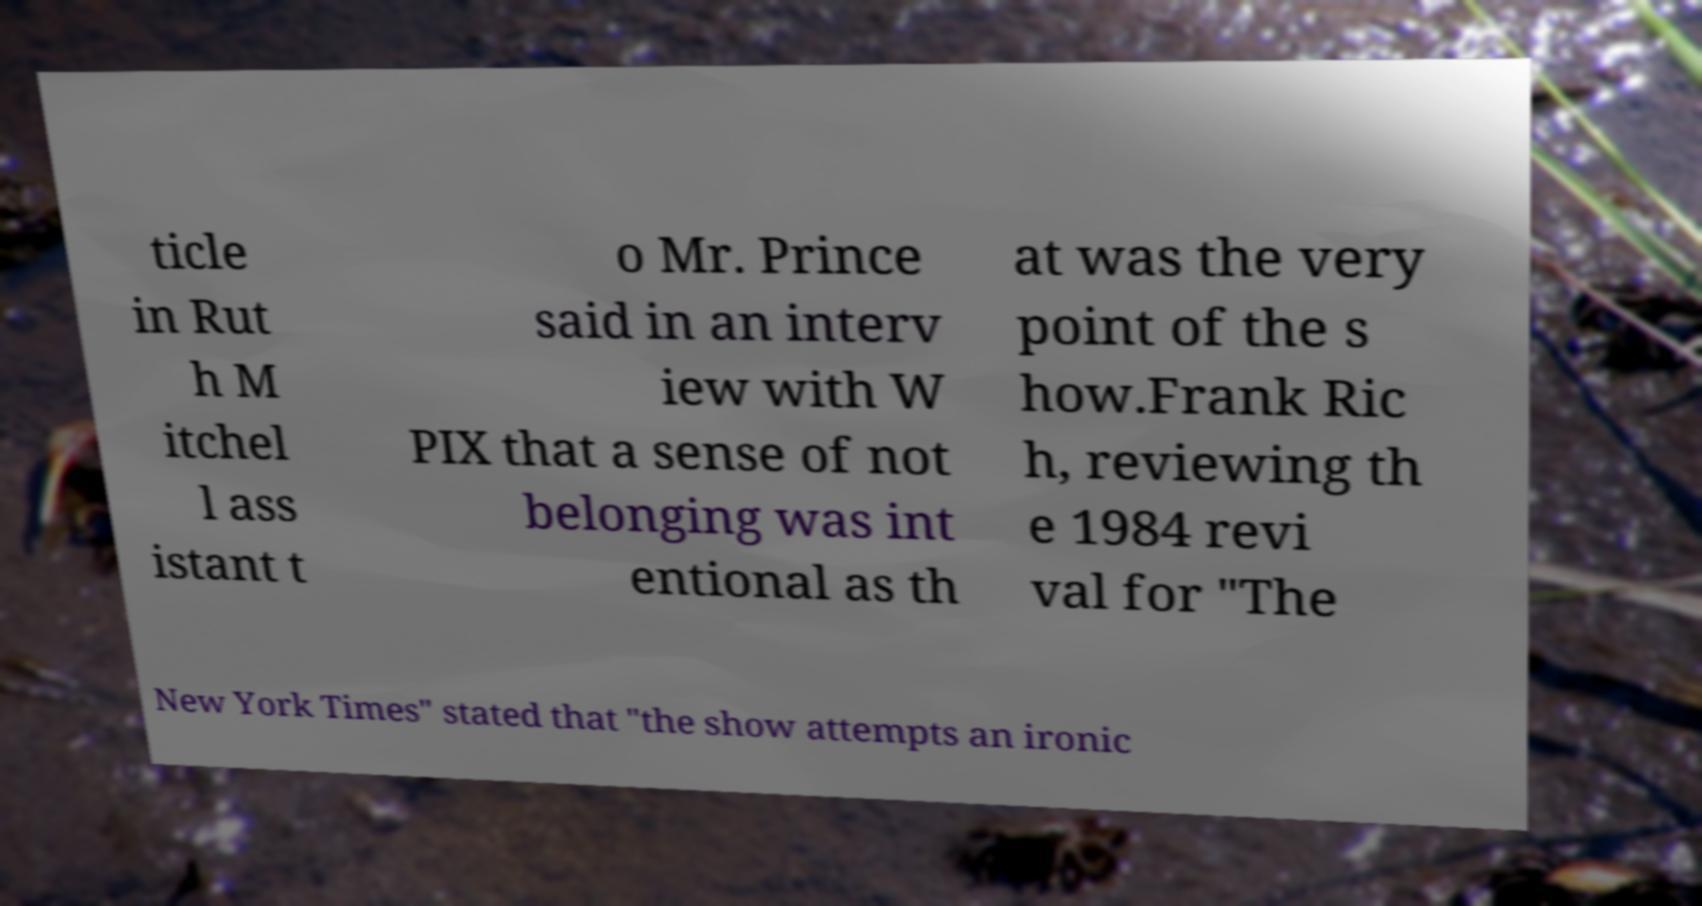There's text embedded in this image that I need extracted. Can you transcribe it verbatim? ticle in Rut h M itchel l ass istant t o Mr. Prince said in an interv iew with W PIX that a sense of not belonging was int entional as th at was the very point of the s how.Frank Ric h, reviewing th e 1984 revi val for "The New York Times" stated that "the show attempts an ironic 